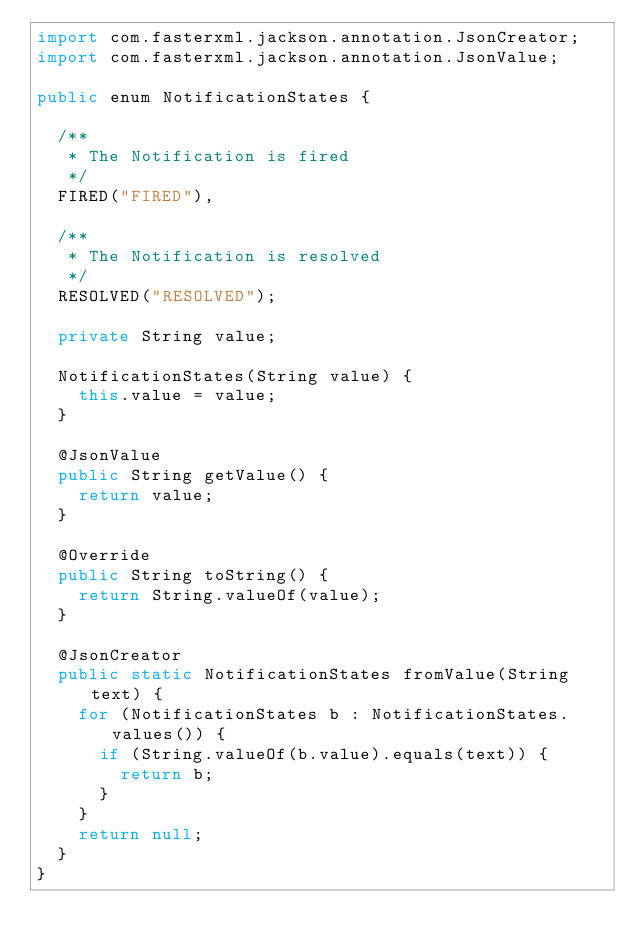<code> <loc_0><loc_0><loc_500><loc_500><_Java_>import com.fasterxml.jackson.annotation.JsonCreator;
import com.fasterxml.jackson.annotation.JsonValue;

public enum NotificationStates {
  
  /**
   * The Notification is fired
   */
  FIRED("FIRED"),
  
  /**
   * The Notification is resolved
   */
  RESOLVED("RESOLVED");

  private String value;

  NotificationStates(String value) {
    this.value = value;
  }

  @JsonValue
  public String getValue() {
    return value;
  }

  @Override
  public String toString() {
    return String.valueOf(value);
  }

  @JsonCreator
  public static NotificationStates fromValue(String text) {
    for (NotificationStates b : NotificationStates.values()) {
      if (String.valueOf(b.value).equals(text)) {
        return b;
      }
    }
    return null;
  }
}

</code> 